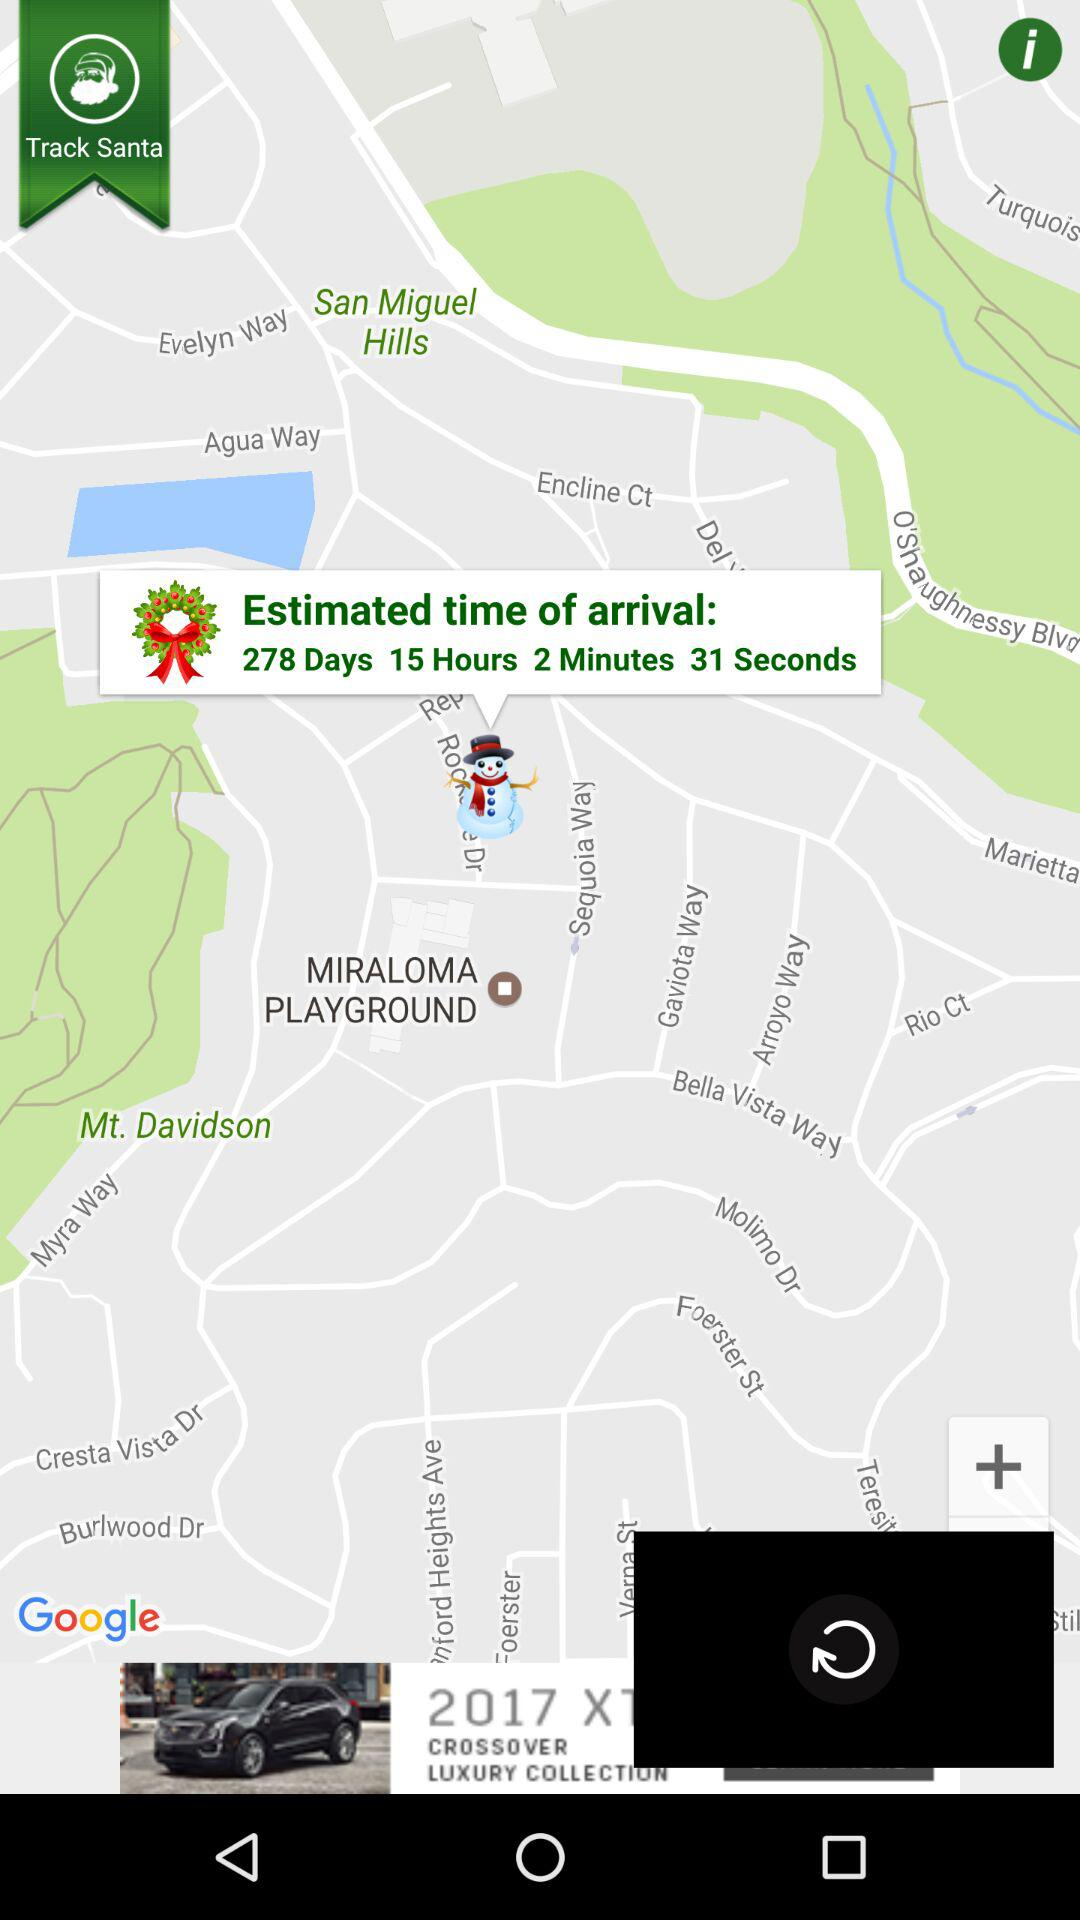What is the estimated time of arrival? The estimated time of arrival is 278 days 15 hours 2 minutes 31 seconds. 